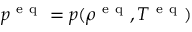Convert formula to latex. <formula><loc_0><loc_0><loc_500><loc_500>p ^ { e q } = p ( \rho ^ { e q } , T ^ { e q } )</formula> 